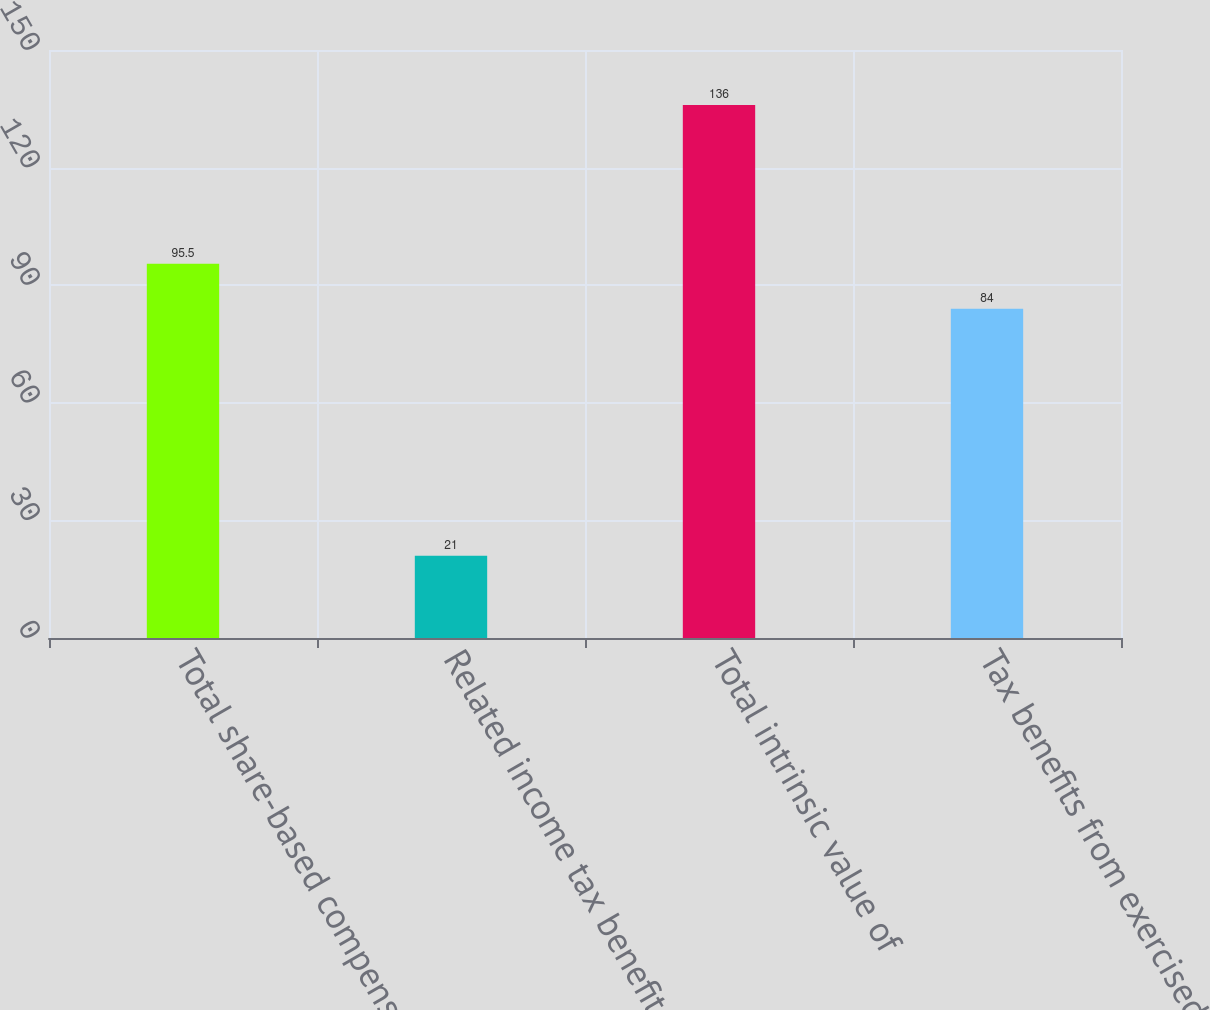Convert chart to OTSL. <chart><loc_0><loc_0><loc_500><loc_500><bar_chart><fcel>Total share-based compensation<fcel>Related income tax benefit<fcel>Total intrinsic value of<fcel>Tax benefits from exercised<nl><fcel>95.5<fcel>21<fcel>136<fcel>84<nl></chart> 